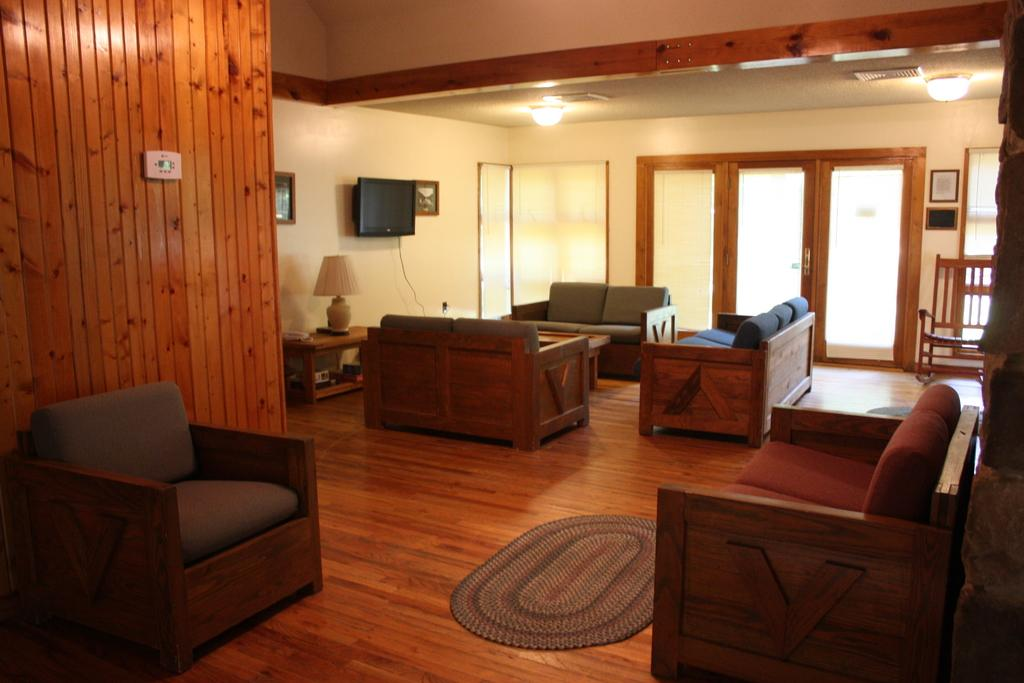What type of furniture is present in the image? There are couches in the image. What is on the floor in the image? There is a mat in the image. What can be seen in the background of the image? There are glass doors, lights on the ceiling, and a television screen in the background of the image. How does the development of the rainstorm affect the image? There is no rainstorm present in the image, so its development does not affect the image. 